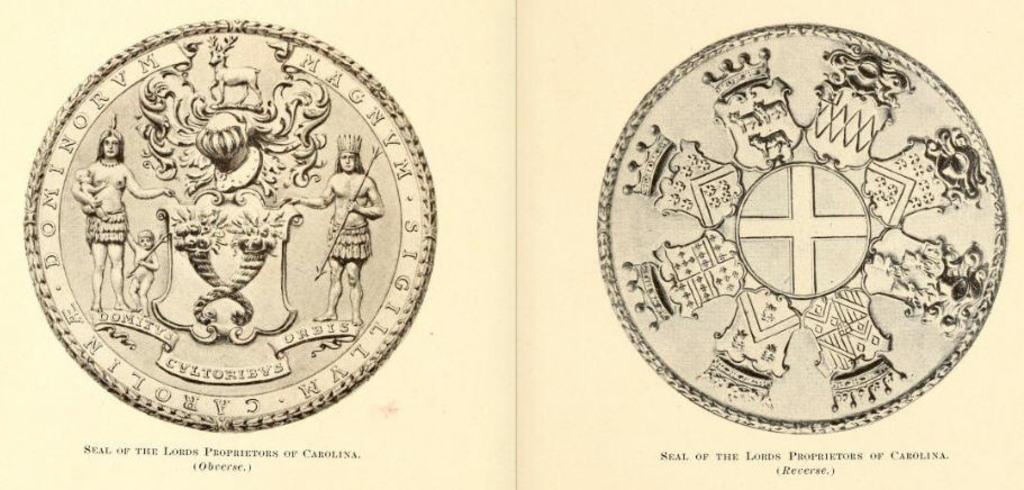Whose seal are these?
Offer a very short reply. Lords proprietors of carolina. Where is the lords proprietors located?
Offer a very short reply. Carolina. 